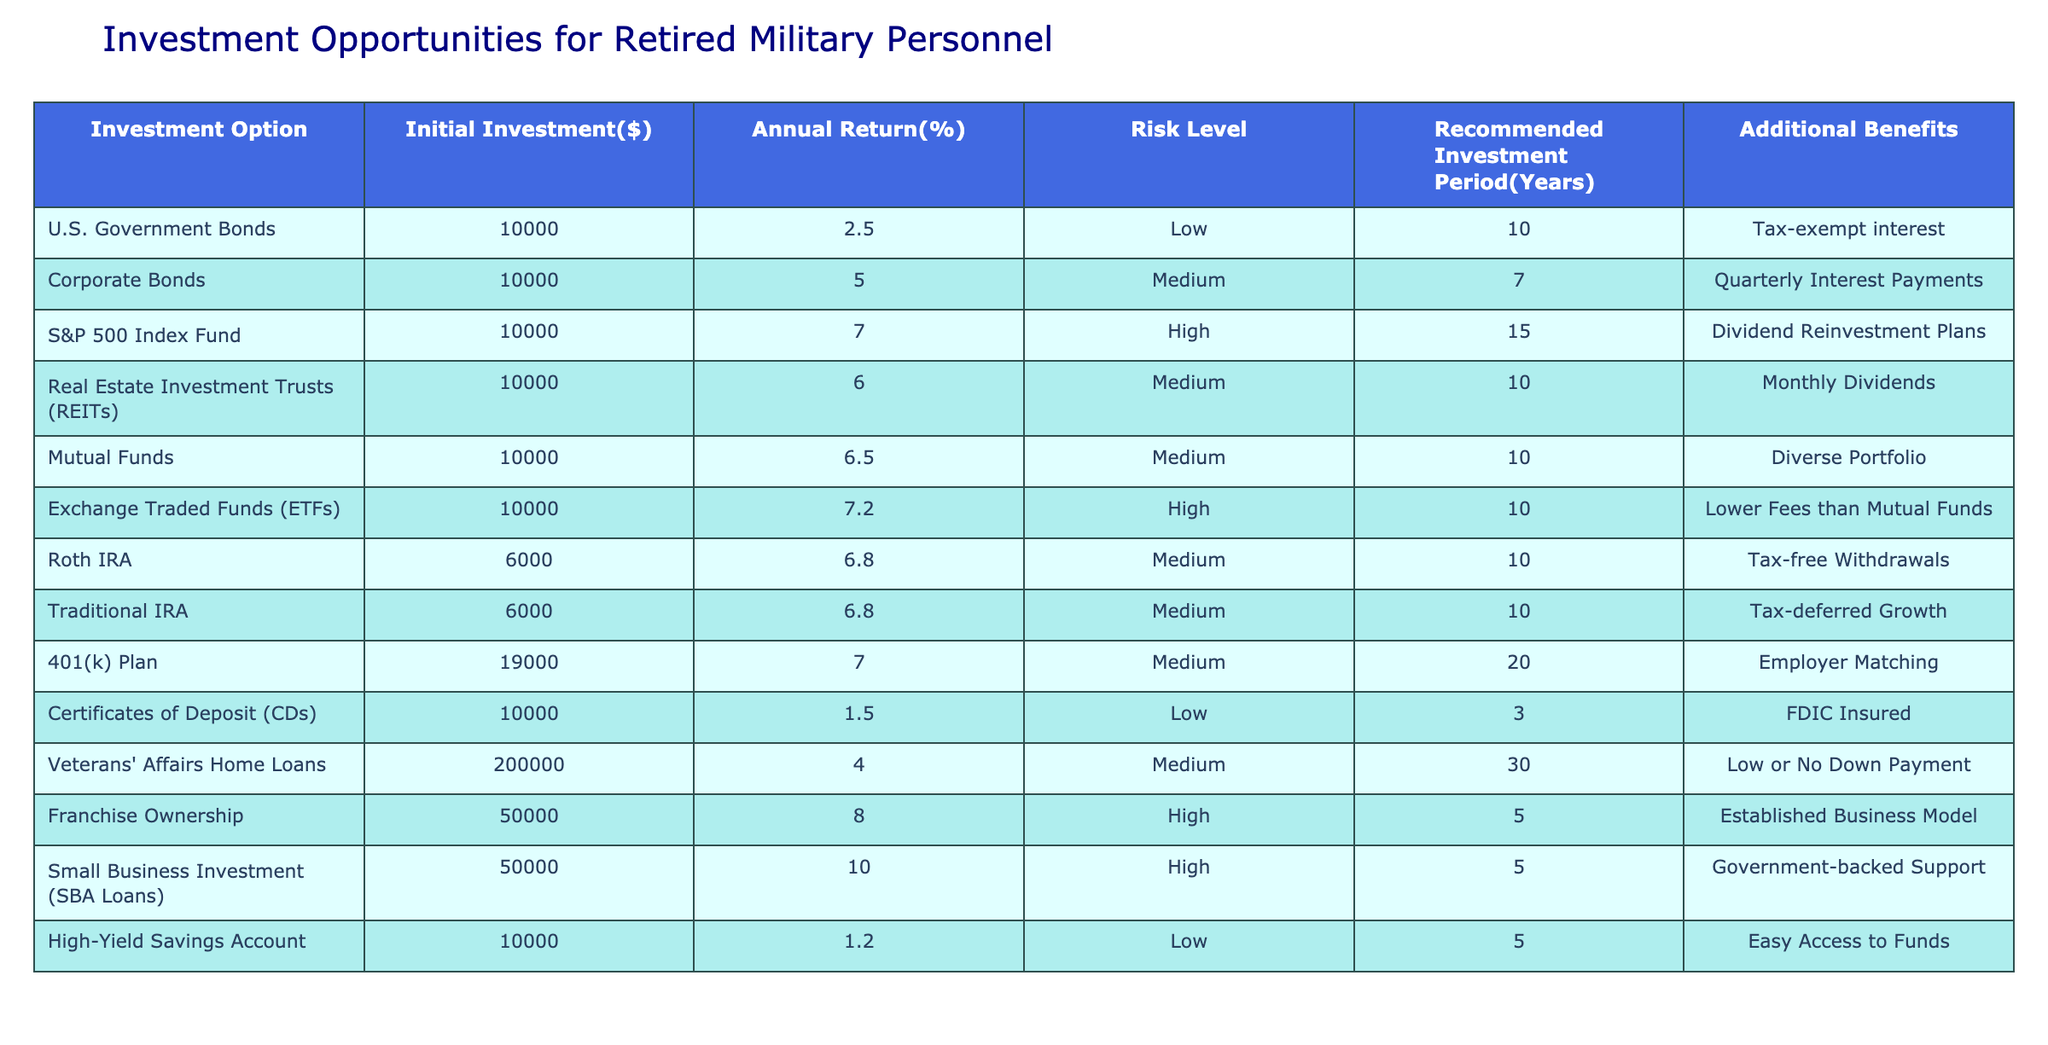What is the highest annual return percentage among the investment options? The investment options are listed with their respective annual returns. The highest annual return is 10% from Small Business Investment (SBA Loans).
Answer: 10% Which investment option has the lowest risk level? The table indicates that the investment options classified as low risk are U.S. Government Bonds and Certificates of Deposit (CDs). U.S. Government Bonds has the lowest risk level.
Answer: U.S. Government Bonds How many investment options are recommended for a period of 10 years? By reviewing the table, the following investment options are recommended for a period of 10 years: U.S. Government Bonds, Real Estate Investment Trusts (REITs), Mutual Funds, Exchange Traded Funds (ETFs), Roth IRA, and Traditional IRA. This totals six options.
Answer: 6 What is the average initial investment for the high-risk investment options? The high-risk options are S&P 500 Index Fund, Exchange Traded Funds (ETFs), Franchise Ownership, and Small Business Investment (SBA Loans). Their initial investments are: 10000, 10000, 50000, and 50000. The sum is 10000 + 10000 + 50000 + 50000 = 120000. Dividing by 4 gives an average of 120000 / 4 = 30000.
Answer: 30000 Is the Annual Return percentage for both the Roth IRA and Traditional IRA the same? Looking at the table, both the Roth IRA and Traditional IRA have an annual return percentage of 6.8%. Therefore, the statement is true.
Answer: Yes Which investment option provides tax-free withdrawals? The table indicates that the Roth IRA offers tax-free withdrawals as one of its additional benefits.
Answer: Roth IRA How many of the investment options have an annual return above 6%? The options with an annual return above 6% are S&P 500 Index Fund (7%), Real Estate Investment Trusts (6%), Mutual Funds (6.5%), Exchange Traded Funds (7.2%), Roth IRA (6.8%), Traditional IRA (6.8%), 401(k) Plan (7%), Franchise Ownership (8%), and Small Business Investment (10%). This counts to a total of 8 options.
Answer: 8 Are Certificates of Deposit considered high-risk investments? The table states that Certificates of Deposit (CDs) are classified as a low-risk investment. Therefore, the statement is false.
Answer: No What additional benefits are associated with Corporate Bonds? According to the table, Corporate Bonds provide the additional benefit of quarterly interest payments.
Answer: Quarterly Interest Payments 